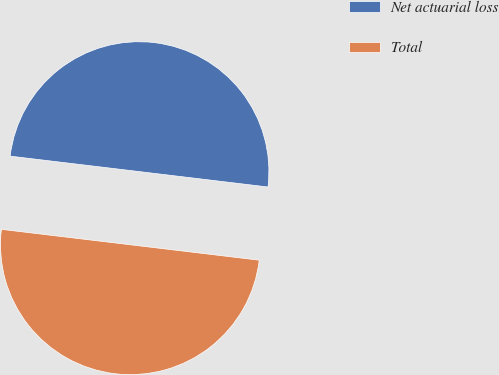Convert chart to OTSL. <chart><loc_0><loc_0><loc_500><loc_500><pie_chart><fcel>Net actuarial loss<fcel>Total<nl><fcel>50.0%<fcel>50.0%<nl></chart> 